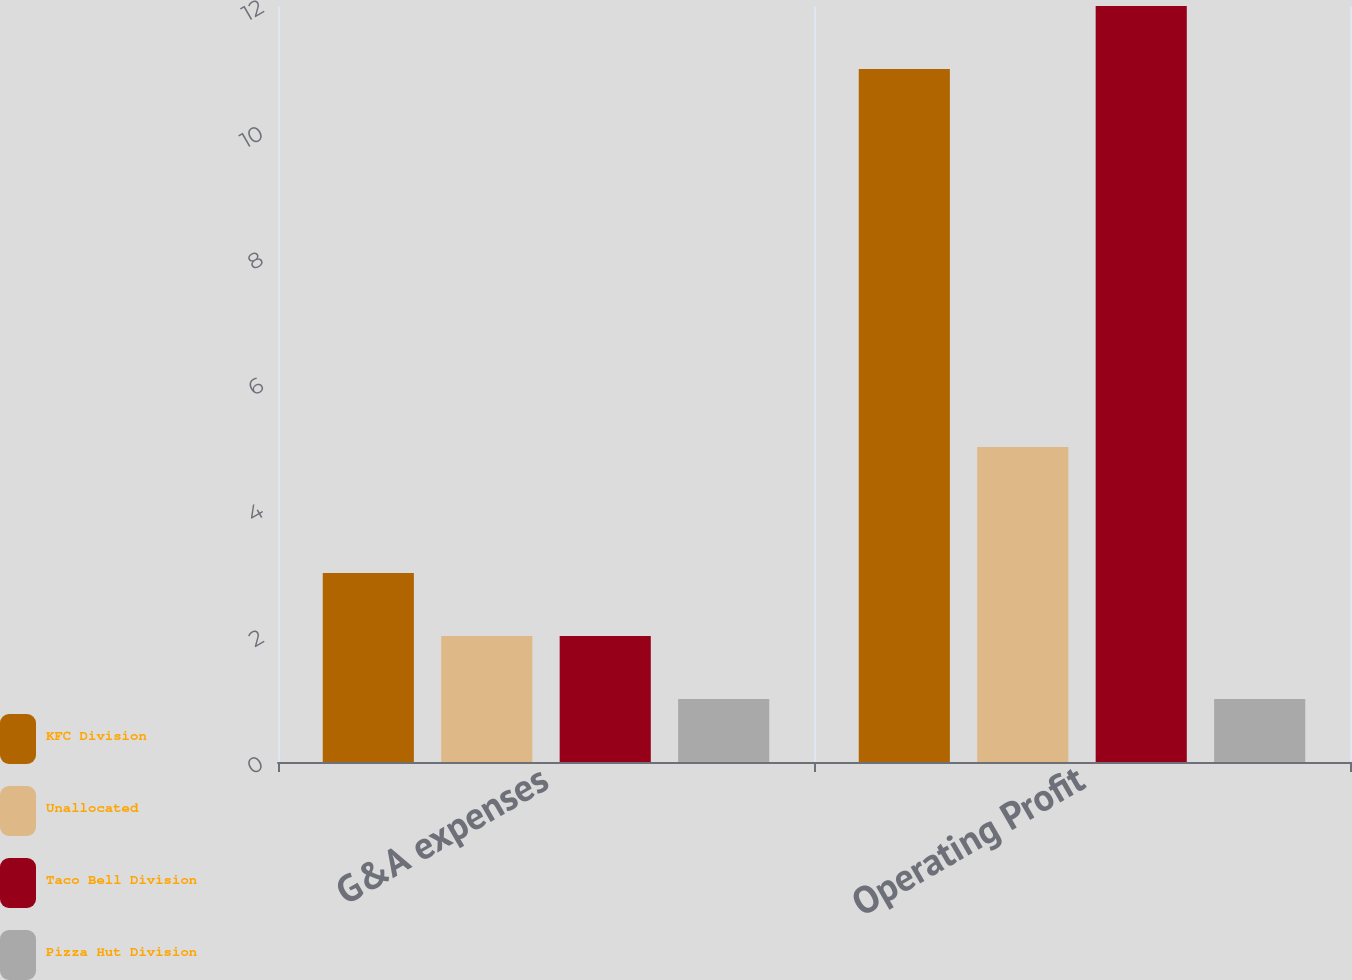Convert chart to OTSL. <chart><loc_0><loc_0><loc_500><loc_500><stacked_bar_chart><ecel><fcel>G&A expenses<fcel>Operating Profit<nl><fcel>KFC Division<fcel>3<fcel>11<nl><fcel>Unallocated<fcel>2<fcel>5<nl><fcel>Taco Bell Division<fcel>2<fcel>12<nl><fcel>Pizza Hut Division<fcel>1<fcel>1<nl></chart> 